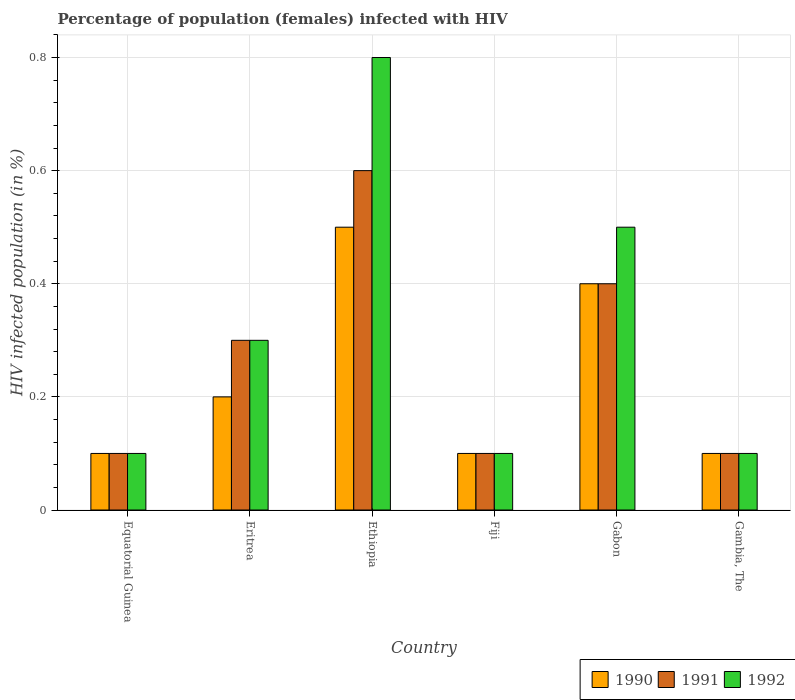Are the number of bars on each tick of the X-axis equal?
Give a very brief answer. Yes. How many bars are there on the 5th tick from the right?
Your answer should be very brief. 3. What is the label of the 3rd group of bars from the left?
Offer a very short reply. Ethiopia. Across all countries, what is the minimum percentage of HIV infected female population in 1991?
Make the answer very short. 0.1. In which country was the percentage of HIV infected female population in 1992 maximum?
Ensure brevity in your answer.  Ethiopia. In which country was the percentage of HIV infected female population in 1992 minimum?
Provide a succinct answer. Equatorial Guinea. What is the total percentage of HIV infected female population in 1991 in the graph?
Provide a succinct answer. 1.6. What is the difference between the percentage of HIV infected female population in 1991 in Equatorial Guinea and that in Fiji?
Provide a succinct answer. 0. What is the difference between the percentage of HIV infected female population in 1990 in Equatorial Guinea and the percentage of HIV infected female population in 1992 in Ethiopia?
Offer a terse response. -0.7. What is the average percentage of HIV infected female population in 1992 per country?
Your answer should be compact. 0.32. What is the difference between the highest and the second highest percentage of HIV infected female population in 1991?
Keep it short and to the point. 0.2. In how many countries, is the percentage of HIV infected female population in 1991 greater than the average percentage of HIV infected female population in 1991 taken over all countries?
Make the answer very short. 3. Is the sum of the percentage of HIV infected female population in 1990 in Equatorial Guinea and Ethiopia greater than the maximum percentage of HIV infected female population in 1991 across all countries?
Provide a succinct answer. No. What does the 1st bar from the left in Gambia, The represents?
Provide a succinct answer. 1990. What does the 2nd bar from the right in Equatorial Guinea represents?
Offer a very short reply. 1991. What is the difference between two consecutive major ticks on the Y-axis?
Provide a succinct answer. 0.2. Are the values on the major ticks of Y-axis written in scientific E-notation?
Offer a terse response. No. Where does the legend appear in the graph?
Your answer should be very brief. Bottom right. How are the legend labels stacked?
Give a very brief answer. Horizontal. What is the title of the graph?
Offer a very short reply. Percentage of population (females) infected with HIV. What is the label or title of the Y-axis?
Your response must be concise. HIV infected population (in %). What is the HIV infected population (in %) in 1991 in Equatorial Guinea?
Your answer should be very brief. 0.1. What is the HIV infected population (in %) of 1992 in Equatorial Guinea?
Give a very brief answer. 0.1. What is the HIV infected population (in %) of 1990 in Eritrea?
Offer a very short reply. 0.2. What is the HIV infected population (in %) in 1991 in Eritrea?
Your answer should be very brief. 0.3. What is the HIV infected population (in %) in 1992 in Eritrea?
Offer a very short reply. 0.3. What is the HIV infected population (in %) in 1990 in Ethiopia?
Your response must be concise. 0.5. What is the HIV infected population (in %) of 1991 in Ethiopia?
Provide a succinct answer. 0.6. What is the HIV infected population (in %) in 1991 in Fiji?
Provide a short and direct response. 0.1. What is the HIV infected population (in %) of 1992 in Fiji?
Give a very brief answer. 0.1. What is the HIV infected population (in %) of 1991 in Gabon?
Keep it short and to the point. 0.4. What is the HIV infected population (in %) in 1992 in Gabon?
Provide a succinct answer. 0.5. What is the HIV infected population (in %) of 1990 in Gambia, The?
Ensure brevity in your answer.  0.1. What is the HIV infected population (in %) in 1991 in Gambia, The?
Make the answer very short. 0.1. What is the HIV infected population (in %) of 1992 in Gambia, The?
Your response must be concise. 0.1. Across all countries, what is the maximum HIV infected population (in %) of 1991?
Make the answer very short. 0.6. Across all countries, what is the maximum HIV infected population (in %) of 1992?
Offer a very short reply. 0.8. Across all countries, what is the minimum HIV infected population (in %) in 1992?
Ensure brevity in your answer.  0.1. What is the total HIV infected population (in %) of 1990 in the graph?
Your answer should be very brief. 1.4. What is the total HIV infected population (in %) in 1992 in the graph?
Keep it short and to the point. 1.9. What is the difference between the HIV infected population (in %) of 1991 in Equatorial Guinea and that in Eritrea?
Your answer should be very brief. -0.2. What is the difference between the HIV infected population (in %) in 1992 in Equatorial Guinea and that in Eritrea?
Keep it short and to the point. -0.2. What is the difference between the HIV infected population (in %) of 1992 in Equatorial Guinea and that in Ethiopia?
Provide a succinct answer. -0.7. What is the difference between the HIV infected population (in %) in 1990 in Equatorial Guinea and that in Fiji?
Ensure brevity in your answer.  0. What is the difference between the HIV infected population (in %) of 1991 in Equatorial Guinea and that in Fiji?
Offer a terse response. 0. What is the difference between the HIV infected population (in %) of 1990 in Equatorial Guinea and that in Gabon?
Keep it short and to the point. -0.3. What is the difference between the HIV infected population (in %) of 1992 in Equatorial Guinea and that in Gabon?
Your answer should be very brief. -0.4. What is the difference between the HIV infected population (in %) of 1991 in Equatorial Guinea and that in Gambia, The?
Ensure brevity in your answer.  0. What is the difference between the HIV infected population (in %) of 1990 in Eritrea and that in Ethiopia?
Make the answer very short. -0.3. What is the difference between the HIV infected population (in %) in 1991 in Eritrea and that in Ethiopia?
Make the answer very short. -0.3. What is the difference between the HIV infected population (in %) of 1992 in Eritrea and that in Ethiopia?
Provide a short and direct response. -0.5. What is the difference between the HIV infected population (in %) of 1990 in Eritrea and that in Fiji?
Offer a very short reply. 0.1. What is the difference between the HIV infected population (in %) in 1990 in Eritrea and that in Gambia, The?
Give a very brief answer. 0.1. What is the difference between the HIV infected population (in %) of 1990 in Ethiopia and that in Fiji?
Provide a short and direct response. 0.4. What is the difference between the HIV infected population (in %) in 1991 in Ethiopia and that in Fiji?
Make the answer very short. 0.5. What is the difference between the HIV infected population (in %) of 1992 in Ethiopia and that in Fiji?
Keep it short and to the point. 0.7. What is the difference between the HIV infected population (in %) of 1990 in Ethiopia and that in Gabon?
Ensure brevity in your answer.  0.1. What is the difference between the HIV infected population (in %) in 1991 in Ethiopia and that in Gabon?
Your answer should be compact. 0.2. What is the difference between the HIV infected population (in %) in 1992 in Ethiopia and that in Gabon?
Ensure brevity in your answer.  0.3. What is the difference between the HIV infected population (in %) of 1992 in Ethiopia and that in Gambia, The?
Give a very brief answer. 0.7. What is the difference between the HIV infected population (in %) of 1990 in Fiji and that in Gabon?
Offer a terse response. -0.3. What is the difference between the HIV infected population (in %) of 1991 in Fiji and that in Gabon?
Your answer should be very brief. -0.3. What is the difference between the HIV infected population (in %) of 1992 in Fiji and that in Gabon?
Offer a terse response. -0.4. What is the difference between the HIV infected population (in %) in 1990 in Fiji and that in Gambia, The?
Give a very brief answer. 0. What is the difference between the HIV infected population (in %) in 1991 in Fiji and that in Gambia, The?
Provide a succinct answer. 0. What is the difference between the HIV infected population (in %) in 1991 in Gabon and that in Gambia, The?
Your answer should be very brief. 0.3. What is the difference between the HIV infected population (in %) in 1992 in Gabon and that in Gambia, The?
Keep it short and to the point. 0.4. What is the difference between the HIV infected population (in %) of 1990 in Equatorial Guinea and the HIV infected population (in %) of 1991 in Eritrea?
Your response must be concise. -0.2. What is the difference between the HIV infected population (in %) of 1991 in Equatorial Guinea and the HIV infected population (in %) of 1992 in Ethiopia?
Offer a very short reply. -0.7. What is the difference between the HIV infected population (in %) in 1990 in Equatorial Guinea and the HIV infected population (in %) in 1991 in Fiji?
Offer a very short reply. 0. What is the difference between the HIV infected population (in %) of 1990 in Equatorial Guinea and the HIV infected population (in %) of 1992 in Gabon?
Your answer should be very brief. -0.4. What is the difference between the HIV infected population (in %) in 1990 in Equatorial Guinea and the HIV infected population (in %) in 1992 in Gambia, The?
Your answer should be compact. 0. What is the difference between the HIV infected population (in %) of 1990 in Eritrea and the HIV infected population (in %) of 1991 in Ethiopia?
Offer a very short reply. -0.4. What is the difference between the HIV infected population (in %) in 1990 in Eritrea and the HIV infected population (in %) in 1992 in Ethiopia?
Provide a short and direct response. -0.6. What is the difference between the HIV infected population (in %) of 1991 in Eritrea and the HIV infected population (in %) of 1992 in Fiji?
Offer a very short reply. 0.2. What is the difference between the HIV infected population (in %) in 1991 in Eritrea and the HIV infected population (in %) in 1992 in Gabon?
Your response must be concise. -0.2. What is the difference between the HIV infected population (in %) of 1990 in Eritrea and the HIV infected population (in %) of 1992 in Gambia, The?
Your answer should be compact. 0.1. What is the difference between the HIV infected population (in %) in 1991 in Eritrea and the HIV infected population (in %) in 1992 in Gambia, The?
Keep it short and to the point. 0.2. What is the difference between the HIV infected population (in %) in 1990 in Ethiopia and the HIV infected population (in %) in 1991 in Fiji?
Ensure brevity in your answer.  0.4. What is the difference between the HIV infected population (in %) of 1991 in Ethiopia and the HIV infected population (in %) of 1992 in Fiji?
Provide a succinct answer. 0.5. What is the difference between the HIV infected population (in %) in 1990 in Ethiopia and the HIV infected population (in %) in 1991 in Gabon?
Ensure brevity in your answer.  0.1. What is the difference between the HIV infected population (in %) of 1990 in Ethiopia and the HIV infected population (in %) of 1992 in Gabon?
Your response must be concise. 0. What is the difference between the HIV infected population (in %) in 1991 in Ethiopia and the HIV infected population (in %) in 1992 in Gabon?
Give a very brief answer. 0.1. What is the difference between the HIV infected population (in %) of 1990 in Ethiopia and the HIV infected population (in %) of 1992 in Gambia, The?
Your response must be concise. 0.4. What is the difference between the HIV infected population (in %) of 1990 in Fiji and the HIV infected population (in %) of 1992 in Gabon?
Offer a terse response. -0.4. What is the difference between the HIV infected population (in %) in 1991 in Fiji and the HIV infected population (in %) in 1992 in Gabon?
Keep it short and to the point. -0.4. What is the difference between the HIV infected population (in %) of 1990 in Fiji and the HIV infected population (in %) of 1991 in Gambia, The?
Your answer should be compact. 0. What is the difference between the HIV infected population (in %) of 1990 in Gabon and the HIV infected population (in %) of 1991 in Gambia, The?
Your answer should be very brief. 0.3. What is the difference between the HIV infected population (in %) of 1990 in Gabon and the HIV infected population (in %) of 1992 in Gambia, The?
Your answer should be compact. 0.3. What is the average HIV infected population (in %) of 1990 per country?
Your response must be concise. 0.23. What is the average HIV infected population (in %) of 1991 per country?
Ensure brevity in your answer.  0.27. What is the average HIV infected population (in %) in 1992 per country?
Your answer should be very brief. 0.32. What is the difference between the HIV infected population (in %) of 1991 and HIV infected population (in %) of 1992 in Eritrea?
Offer a terse response. 0. What is the difference between the HIV infected population (in %) of 1990 and HIV infected population (in %) of 1991 in Ethiopia?
Your answer should be very brief. -0.1. What is the difference between the HIV infected population (in %) in 1991 and HIV infected population (in %) in 1992 in Ethiopia?
Your answer should be very brief. -0.2. What is the difference between the HIV infected population (in %) of 1990 and HIV infected population (in %) of 1992 in Fiji?
Make the answer very short. 0. What is the difference between the HIV infected population (in %) of 1991 and HIV infected population (in %) of 1992 in Fiji?
Keep it short and to the point. 0. What is the difference between the HIV infected population (in %) of 1990 and HIV infected population (in %) of 1992 in Gabon?
Give a very brief answer. -0.1. What is the difference between the HIV infected population (in %) in 1990 and HIV infected population (in %) in 1992 in Gambia, The?
Ensure brevity in your answer.  0. What is the ratio of the HIV infected population (in %) in 1990 in Equatorial Guinea to that in Eritrea?
Your answer should be very brief. 0.5. What is the ratio of the HIV infected population (in %) of 1990 in Equatorial Guinea to that in Fiji?
Offer a very short reply. 1. What is the ratio of the HIV infected population (in %) of 1991 in Equatorial Guinea to that in Fiji?
Your response must be concise. 1. What is the ratio of the HIV infected population (in %) in 1990 in Equatorial Guinea to that in Gabon?
Provide a short and direct response. 0.25. What is the ratio of the HIV infected population (in %) of 1991 in Equatorial Guinea to that in Gabon?
Offer a very short reply. 0.25. What is the ratio of the HIV infected population (in %) of 1991 in Equatorial Guinea to that in Gambia, The?
Make the answer very short. 1. What is the ratio of the HIV infected population (in %) of 1992 in Equatorial Guinea to that in Gambia, The?
Offer a very short reply. 1. What is the ratio of the HIV infected population (in %) of 1990 in Eritrea to that in Ethiopia?
Ensure brevity in your answer.  0.4. What is the ratio of the HIV infected population (in %) of 1991 in Eritrea to that in Ethiopia?
Give a very brief answer. 0.5. What is the ratio of the HIV infected population (in %) of 1992 in Eritrea to that in Fiji?
Your answer should be very brief. 3. What is the ratio of the HIV infected population (in %) in 1991 in Eritrea to that in Gabon?
Your answer should be very brief. 0.75. What is the ratio of the HIV infected population (in %) of 1992 in Eritrea to that in Gabon?
Provide a short and direct response. 0.6. What is the ratio of the HIV infected population (in %) of 1991 in Eritrea to that in Gambia, The?
Make the answer very short. 3. What is the ratio of the HIV infected population (in %) in 1992 in Ethiopia to that in Gambia, The?
Keep it short and to the point. 8. What is the ratio of the HIV infected population (in %) in 1991 in Fiji to that in Gabon?
Your answer should be compact. 0.25. What is the ratio of the HIV infected population (in %) of 1992 in Fiji to that in Gabon?
Provide a short and direct response. 0.2. What is the ratio of the HIV infected population (in %) of 1990 in Gabon to that in Gambia, The?
Ensure brevity in your answer.  4. What is the ratio of the HIV infected population (in %) in 1991 in Gabon to that in Gambia, The?
Keep it short and to the point. 4. What is the ratio of the HIV infected population (in %) in 1992 in Gabon to that in Gambia, The?
Ensure brevity in your answer.  5. What is the difference between the highest and the second highest HIV infected population (in %) in 1990?
Your answer should be compact. 0.1. What is the difference between the highest and the second highest HIV infected population (in %) in 1991?
Give a very brief answer. 0.2. What is the difference between the highest and the second highest HIV infected population (in %) of 1992?
Ensure brevity in your answer.  0.3. What is the difference between the highest and the lowest HIV infected population (in %) in 1990?
Offer a terse response. 0.4. What is the difference between the highest and the lowest HIV infected population (in %) of 1992?
Make the answer very short. 0.7. 